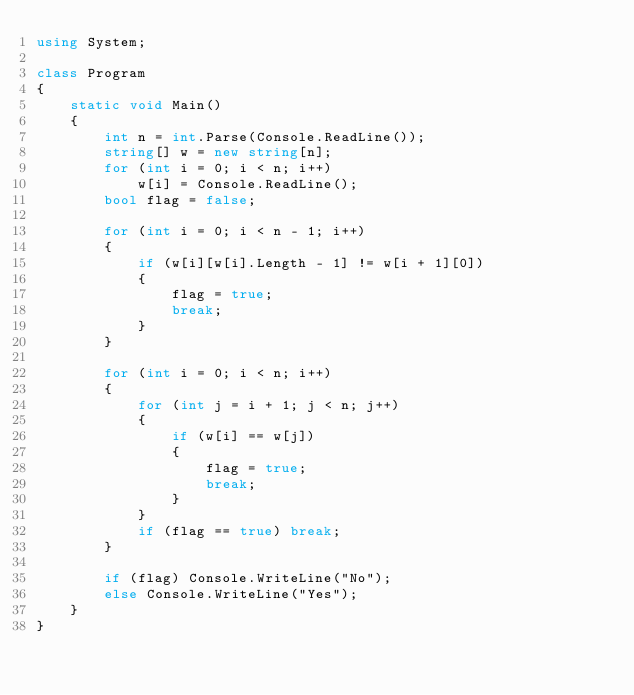<code> <loc_0><loc_0><loc_500><loc_500><_C#_>using System;

class Program
{
    static void Main()
    {
        int n = int.Parse(Console.ReadLine());
        string[] w = new string[n];
        for (int i = 0; i < n; i++)
            w[i] = Console.ReadLine();
        bool flag = false;

        for (int i = 0; i < n - 1; i++)
        {
            if (w[i][w[i].Length - 1] != w[i + 1][0])
            {
                flag = true;
                break;
            }
        }

        for (int i = 0; i < n; i++)
        {
            for (int j = i + 1; j < n; j++)
            {
                if (w[i] == w[j])
                {
                    flag = true;
                    break;
                }
            }
            if (flag == true) break;
        }

        if (flag) Console.WriteLine("No");
        else Console.WriteLine("Yes");
    }
}</code> 